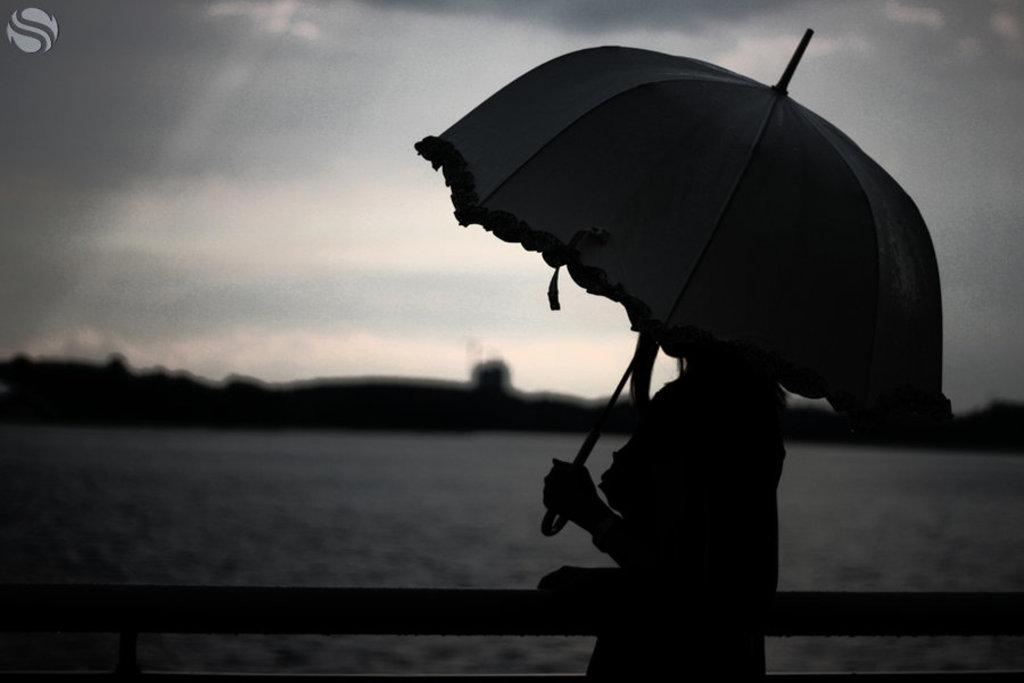What is the main subject of the image? There is a person in the image. What is the person holding in the image? The person is holding an umbrella. What can be seen in the background of the image? There is water visible in the background of the image. What is the color scheme of the image? The image is in black and white. How many ladybugs can be seen on the person's shoulder in the image? There are no ladybugs present in the image. What type of maid is attending to the person in the image? There is no maid present in the image. 